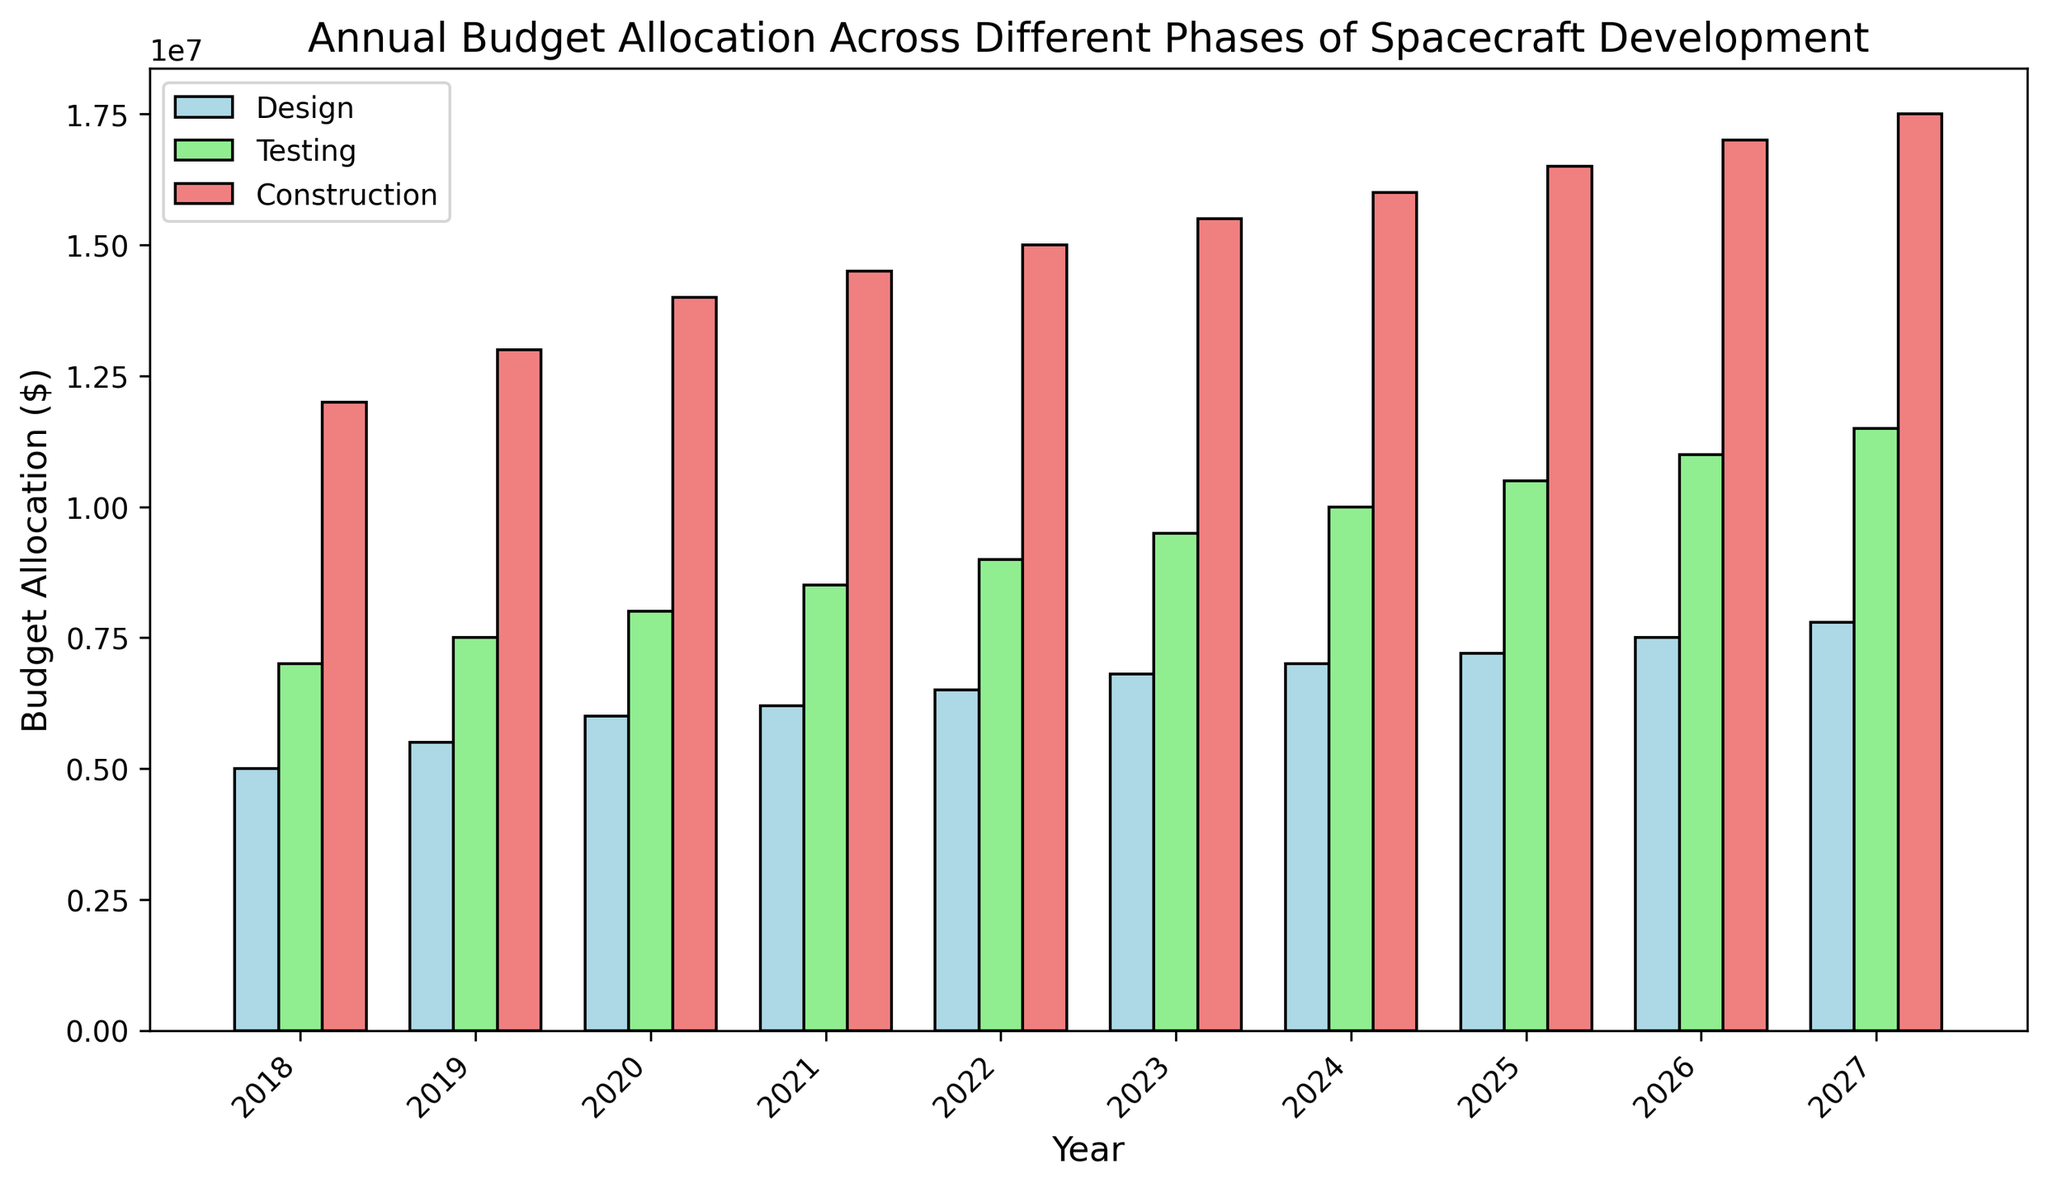What year had the highest budget allocation for Construction? By looking at the heights of the bars for Construction (color: lightcoral), the highest bar corresponds to the year 2027.
Answer: 2027 Which phase had the lowest budget allocation in 2023? Compare the heights of the bars for 2023. The shortest bar is for the Design phase.
Answer: Design How much did the budget allocation for Testing increase from 2018 to 2022? Identify the Testing budget for 2018 ($7,000,000) and for 2022 ($9,000,000). Subtract the 2018 value from the 2022 value: $9,000,000 - $7,000,000 = $2,000,000.
Answer: $2,000,000 What is the average annual budget allocation for Design from 2018 to 2027? Sum up the budget allocations for Design from each year (Sum = $5000000 + $5500000 + $6000000 + $6200000 + $6500000 + $6800000 + $7000000 + $7200000 + $7500000 + $7800000) = $65500000. Divide by the number of years (10): $65500000/10 = $6550000.
Answer: $6550000 In which year did the Testing phase's budget surpass the Design phase's budget by more than $2,500,000? Compare the difference between Testing and Design for each year. In 2018, the difference is $2,000,000. In 2019, the difference is $2,000,000. In 2020, the difference is $2,000,000. In 2021, the difference is $2,300,000. In 2022, the difference is $2,500,000. In 2023, the difference is $2,700,000 (first year surpassing $2,500,000).
Answer: 2023 How much total budget was allocated across all phases in 2020? Sum the budget allocations for all phases in 2020: $6,000,000 (Design) + $8,000,000 (Testing) + $14,000,000 (Construction) = $28,000,000.
Answer: $28,000,000 Which phase saw the highest increase in budget allocation from 2018 to 2027? Calculate the increase for each phase from 2018 to 2027. 
Design: $7,800,000 - $5,000,000 = $2,800,000 
Testing: $11,500,000 - $7,000,000 = $4,500,000 
Construction: $17,500,000 - $12,000,000 = $5,500,000 
The highest increase is in the Construction phase.
Answer: Construction By how much did the Construction budget exceed the sum of Design and Testing budgets in 2019? Calculate the sum of Design and Testing budgets in 2019: $5,500,000 (Design) + $7,500,000 (Testing) = $13,000,000. The Construction budget in 2019 is $13,000,000. Therefore, the difference is $13,000,000 (Construction) - $13,000,000 (sum of Design and Testing) = $0.
Answer: $0 